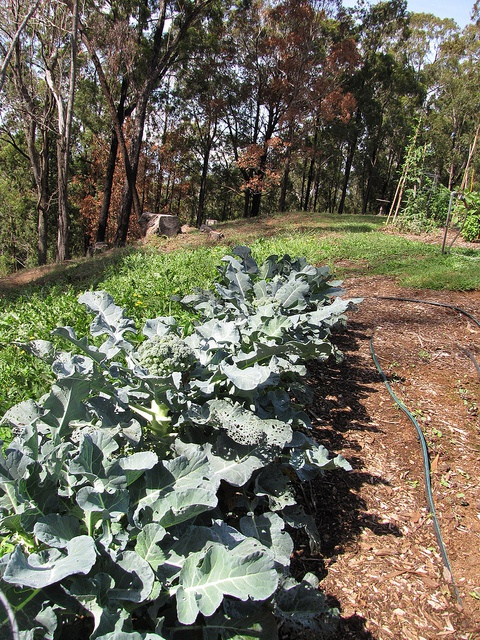Describe the objects in this image and their specific colors. I can see a broccoli in gray, black, and darkgreen tones in this image. 